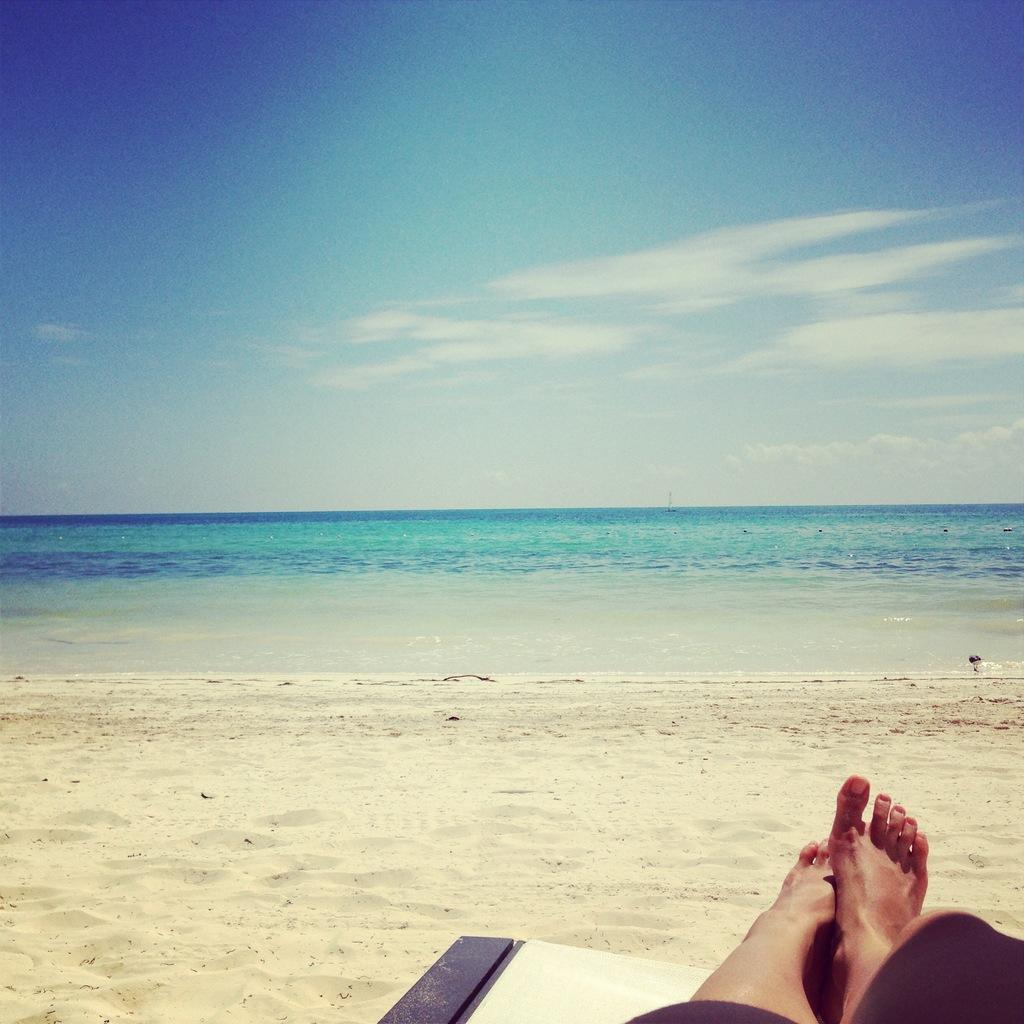What body part of a person is visible in the image? There are a person's legs visible in the image. What is the person's legs resting on? The person's legs are on an object. What type of natural environment is visible in the background of the image? There is sand and water in the background of the image. What can be seen in the sky in the background of the image? There are clouds in the sky in the background of the image. What type of treatment is the girl receiving from the farmer in the image? There is no girl or farmer present in the image, so no such treatment can be observed. 